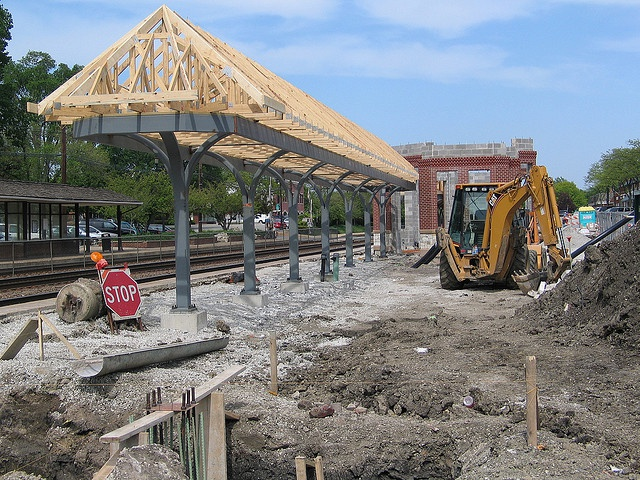Describe the objects in this image and their specific colors. I can see stop sign in blue, brown, lightgray, and maroon tones, car in blue, black, gray, darkgray, and purple tones, car in blue, gray, black, and darkblue tones, car in blue, gray, darkgray, and white tones, and car in blue, black, gray, and darkgray tones in this image. 